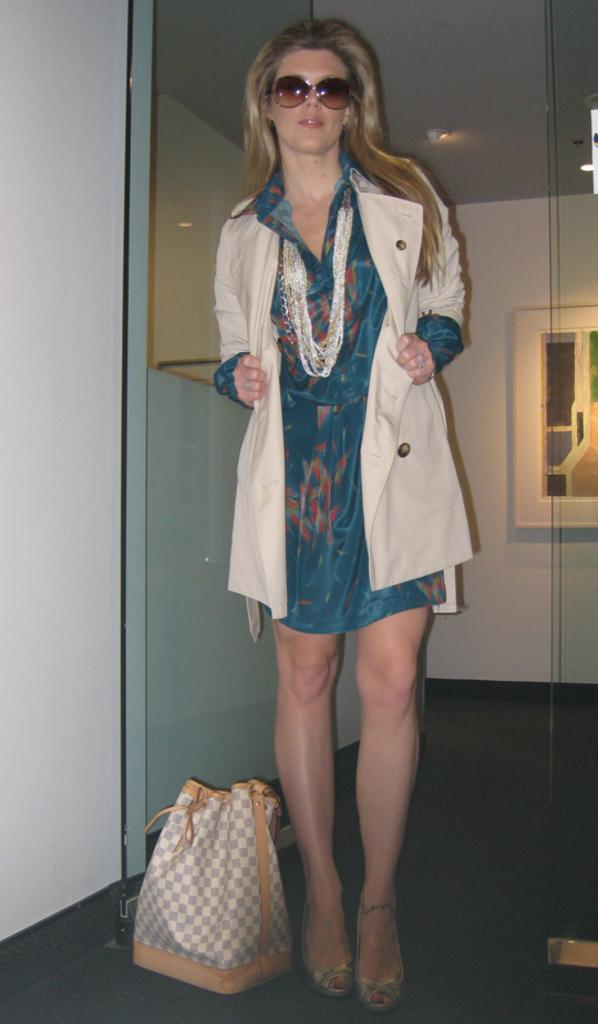What is the main subject of the image? The main subject of the image is a woman standing on the floor. What is located beside the woman? There is a bag beside the woman. What can be seen in the background of the image? The background of the image includes a wall. What is the woman wearing in the image? The woman is wearing a jacket and spectacles. What type of list is the woman holding in the image? There is no list present in the image; the woman is not holding anything. 